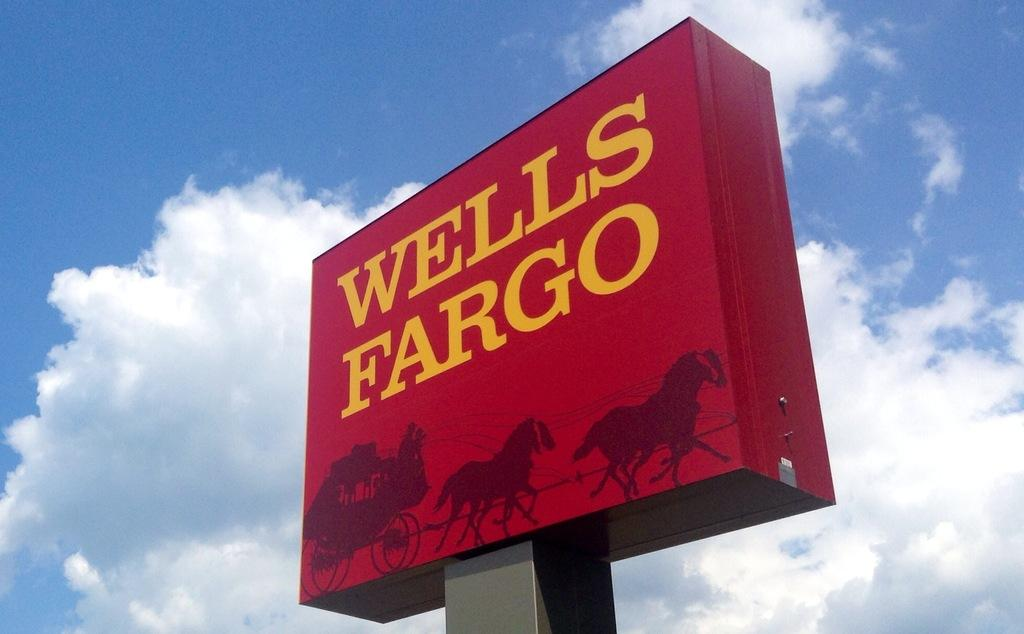<image>
Describe the image concisely. A red sign with the words Wells Fargo in yellow. 